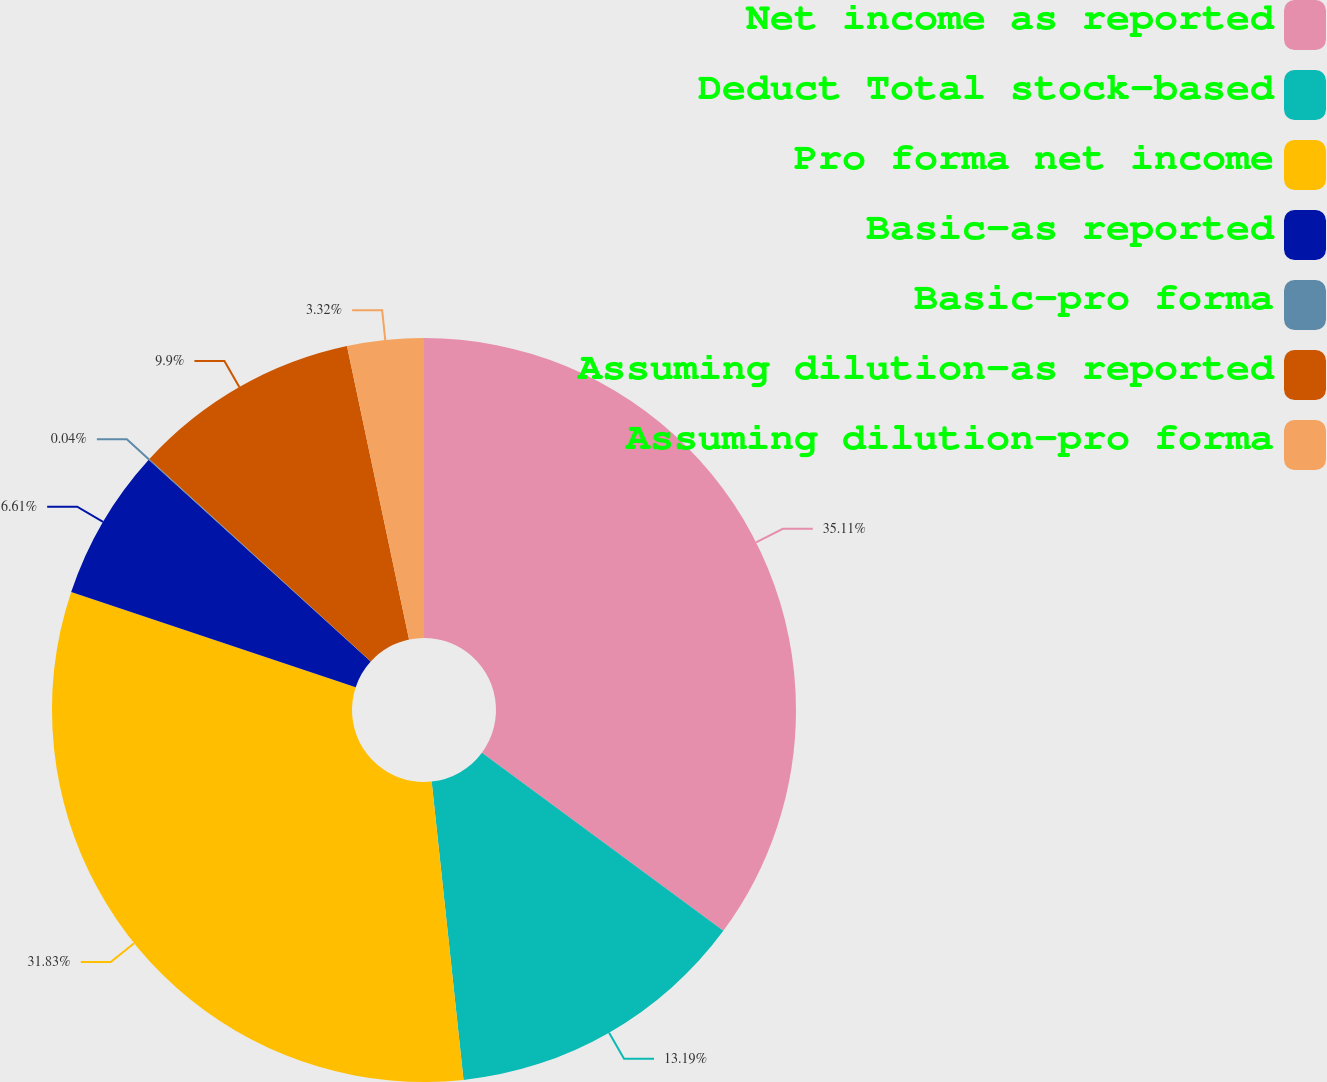Convert chart to OTSL. <chart><loc_0><loc_0><loc_500><loc_500><pie_chart><fcel>Net income as reported<fcel>Deduct Total stock-based<fcel>Pro forma net income<fcel>Basic-as reported<fcel>Basic-pro forma<fcel>Assuming dilution-as reported<fcel>Assuming dilution-pro forma<nl><fcel>35.12%<fcel>13.19%<fcel>31.83%<fcel>6.61%<fcel>0.04%<fcel>9.9%<fcel>3.32%<nl></chart> 